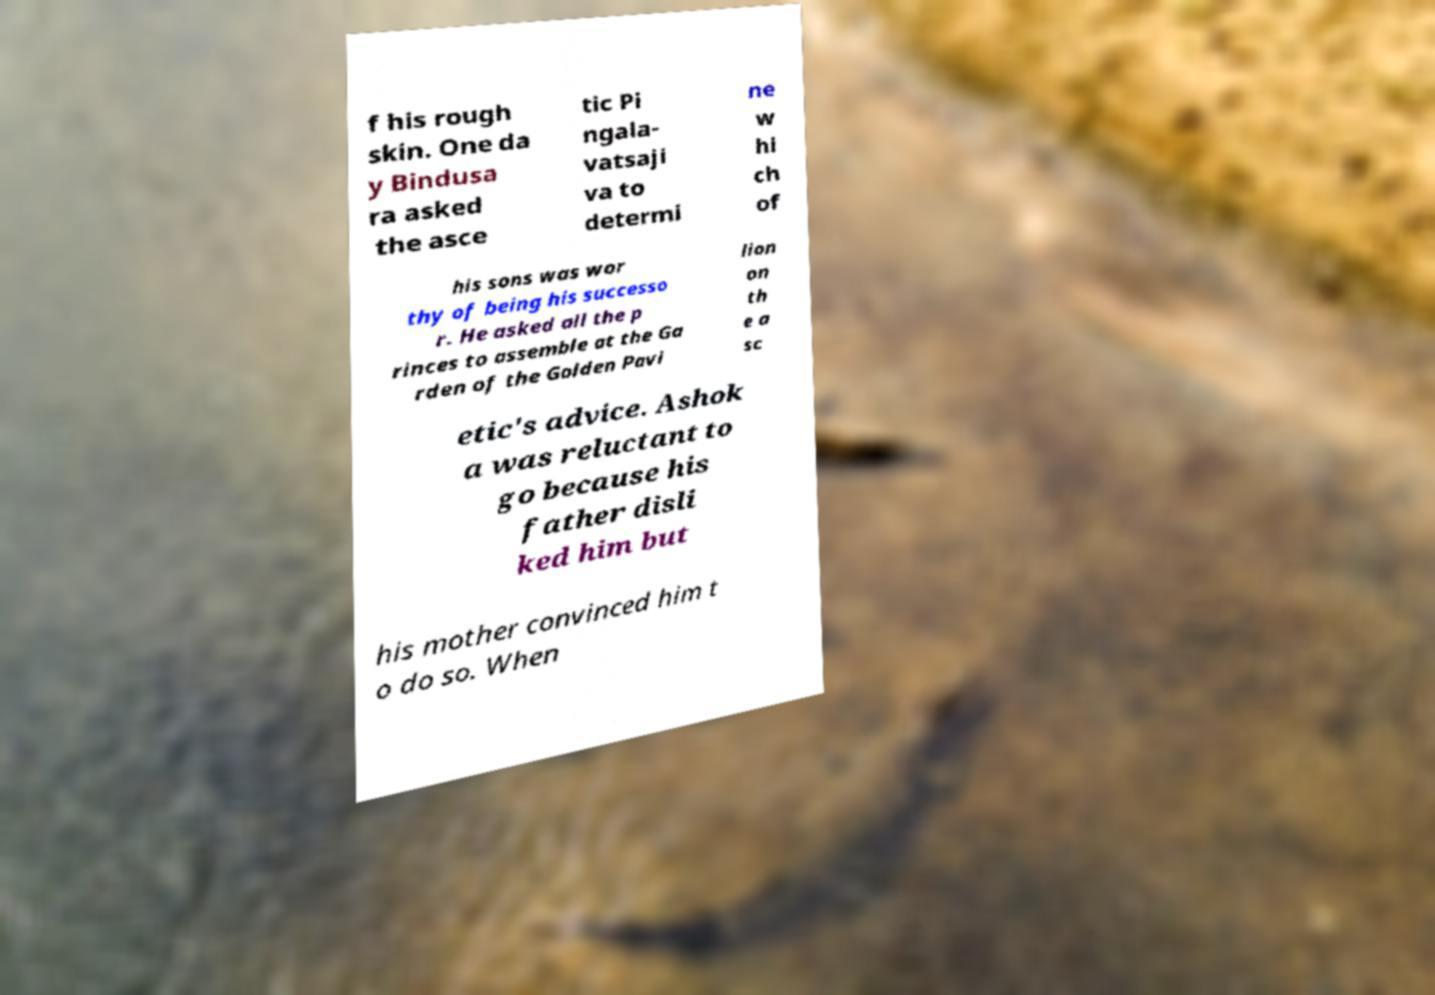Could you extract and type out the text from this image? f his rough skin. One da y Bindusa ra asked the asce tic Pi ngala- vatsaji va to determi ne w hi ch of his sons was wor thy of being his successo r. He asked all the p rinces to assemble at the Ga rden of the Golden Pavi lion on th e a sc etic's advice. Ashok a was reluctant to go because his father disli ked him but his mother convinced him t o do so. When 